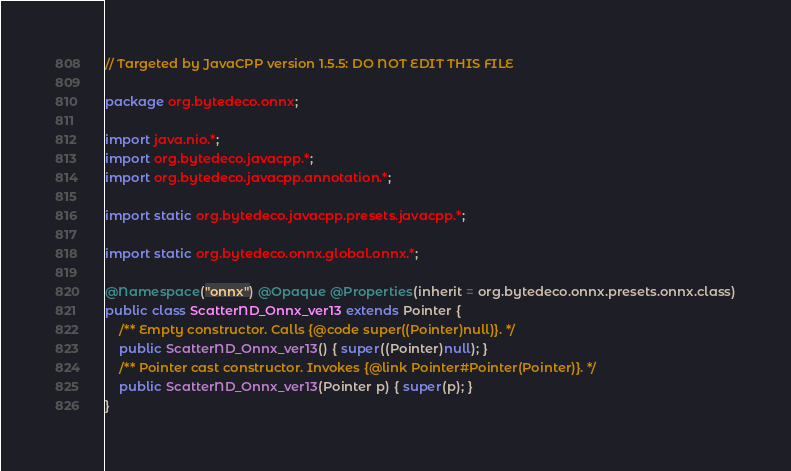<code> <loc_0><loc_0><loc_500><loc_500><_Java_>// Targeted by JavaCPP version 1.5.5: DO NOT EDIT THIS FILE

package org.bytedeco.onnx;

import java.nio.*;
import org.bytedeco.javacpp.*;
import org.bytedeco.javacpp.annotation.*;

import static org.bytedeco.javacpp.presets.javacpp.*;

import static org.bytedeco.onnx.global.onnx.*;

@Namespace("onnx") @Opaque @Properties(inherit = org.bytedeco.onnx.presets.onnx.class)
public class ScatterND_Onnx_ver13 extends Pointer {
    /** Empty constructor. Calls {@code super((Pointer)null)}. */
    public ScatterND_Onnx_ver13() { super((Pointer)null); }
    /** Pointer cast constructor. Invokes {@link Pointer#Pointer(Pointer)}. */
    public ScatterND_Onnx_ver13(Pointer p) { super(p); }
}
</code> 